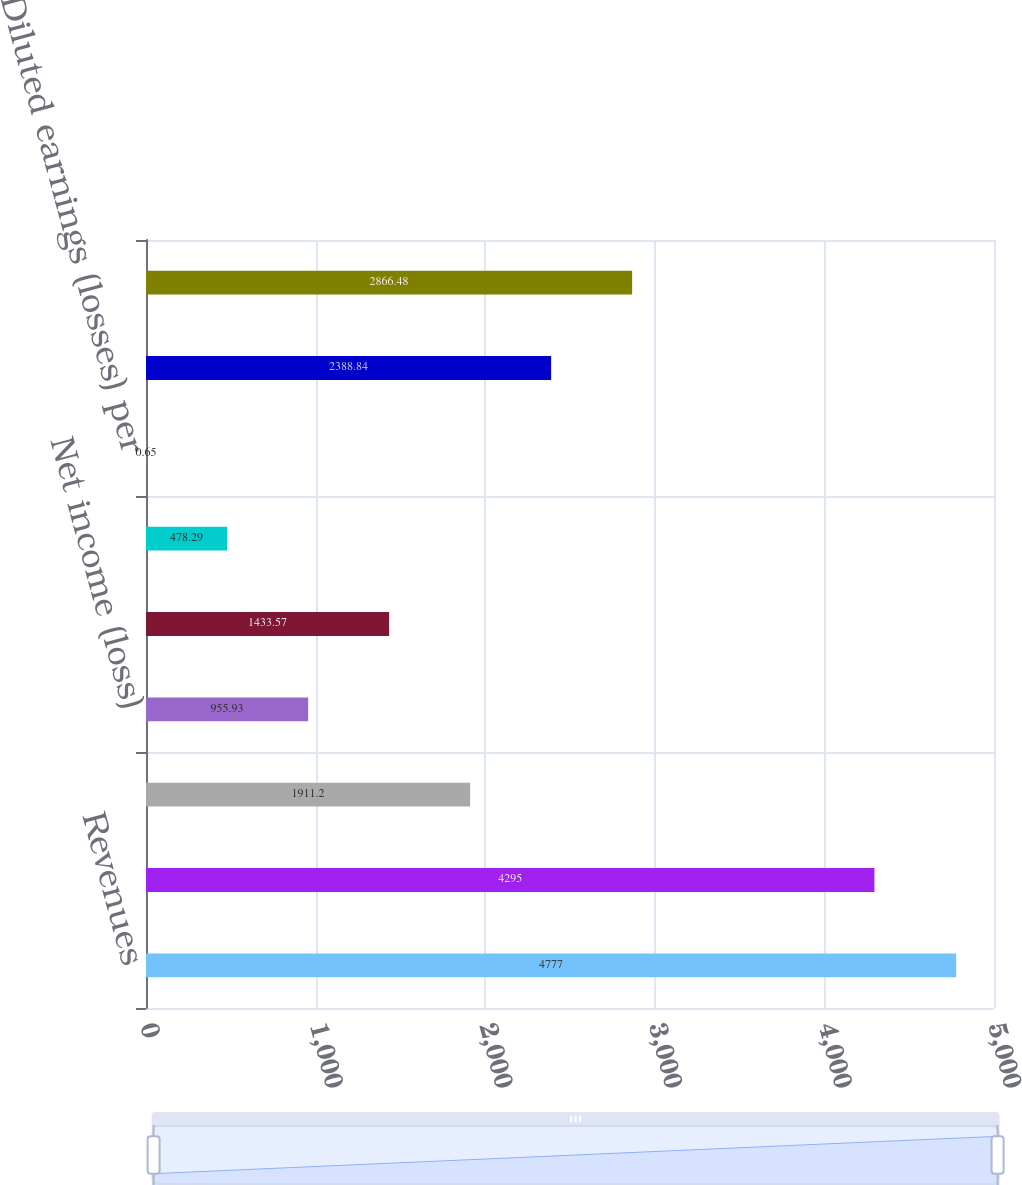Convert chart to OTSL. <chart><loc_0><loc_0><loc_500><loc_500><bar_chart><fcel>Revenues<fcel>Benefits losses and expenses<fcel>Income from continuing<fcel>Net income (loss)<fcel>Net income (loss) available to<fcel>Basic earnings (losses) per<fcel>Diluted earnings (losses) per<fcel>Weighted average common shares<fcel>Weighted average shares<nl><fcel>4777<fcel>4295<fcel>1911.2<fcel>955.93<fcel>1433.57<fcel>478.29<fcel>0.65<fcel>2388.84<fcel>2866.48<nl></chart> 